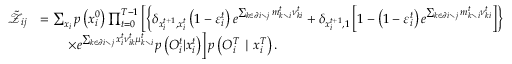Convert formula to latex. <formula><loc_0><loc_0><loc_500><loc_500>\begin{array} { r l } { \tilde { \mathcal { Z } } _ { i j } } & { = \sum _ { x _ { i } } p \left ( x _ { i } ^ { 0 } \right ) \prod _ { t = 0 } ^ { T - 1 } \left [ \left \{ \delta _ { x _ { i } ^ { t + 1 } , x _ { i } ^ { t } } \left ( 1 - \varepsilon _ { i } ^ { t } \right ) e ^ { \sum _ { k \in \partial i \ j } m _ { k \ i } ^ { t } \nu _ { k i } ^ { t } } + \delta _ { x _ { i } ^ { t + 1 } , 1 } \left [ 1 - \left ( 1 - \varepsilon _ { i } ^ { t } \right ) e ^ { \sum _ { k \in \partial i \ j } m _ { k \ i } ^ { t } \nu _ { k i } ^ { t } } \right ] \right \} } \\ & { \quad \times e ^ { \sum _ { k \in \partial i \ j } x _ { i } ^ { t } \nu _ { i k } ^ { t } \mu _ { k \ i } ^ { t } } p \left ( { O } _ { i } ^ { t } | x _ { i } ^ { t } \right ) \right ] p \left ( { O } _ { i } ^ { T } | x _ { i } ^ { T } \right ) . } \end{array}</formula> 